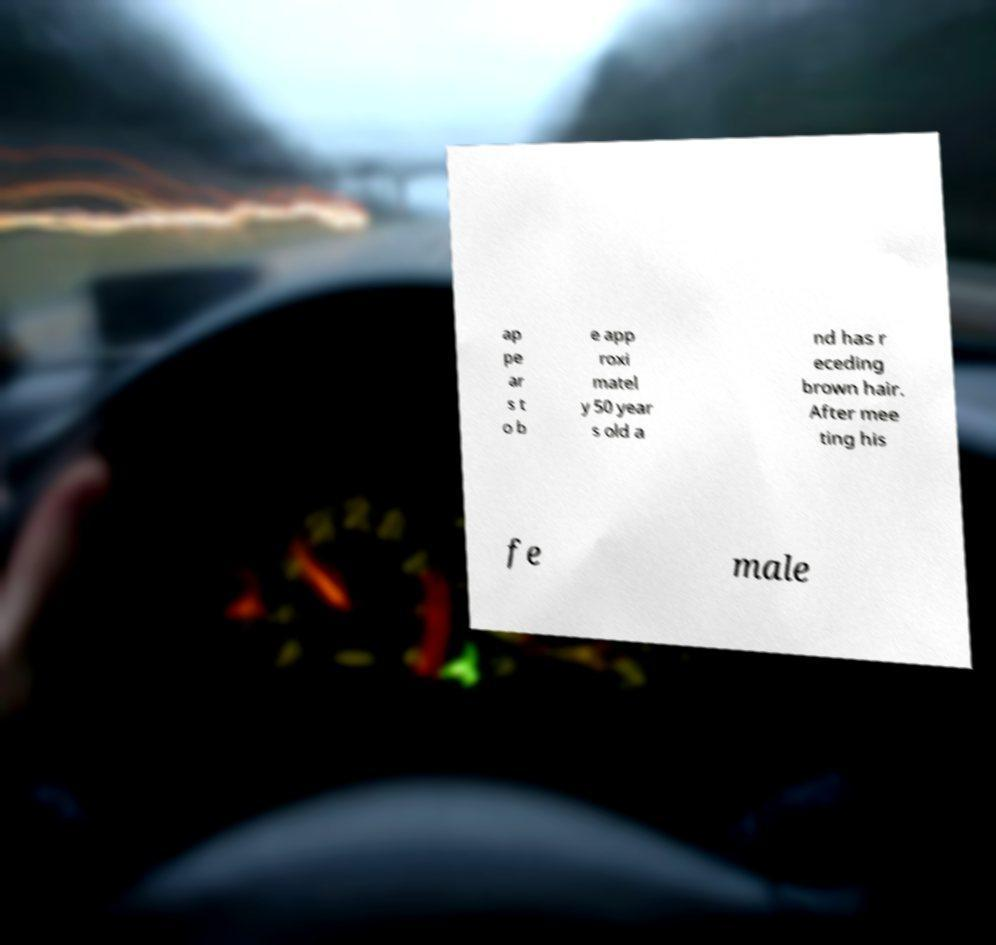Please identify and transcribe the text found in this image. ap pe ar s t o b e app roxi matel y 50 year s old a nd has r eceding brown hair. After mee ting his fe male 